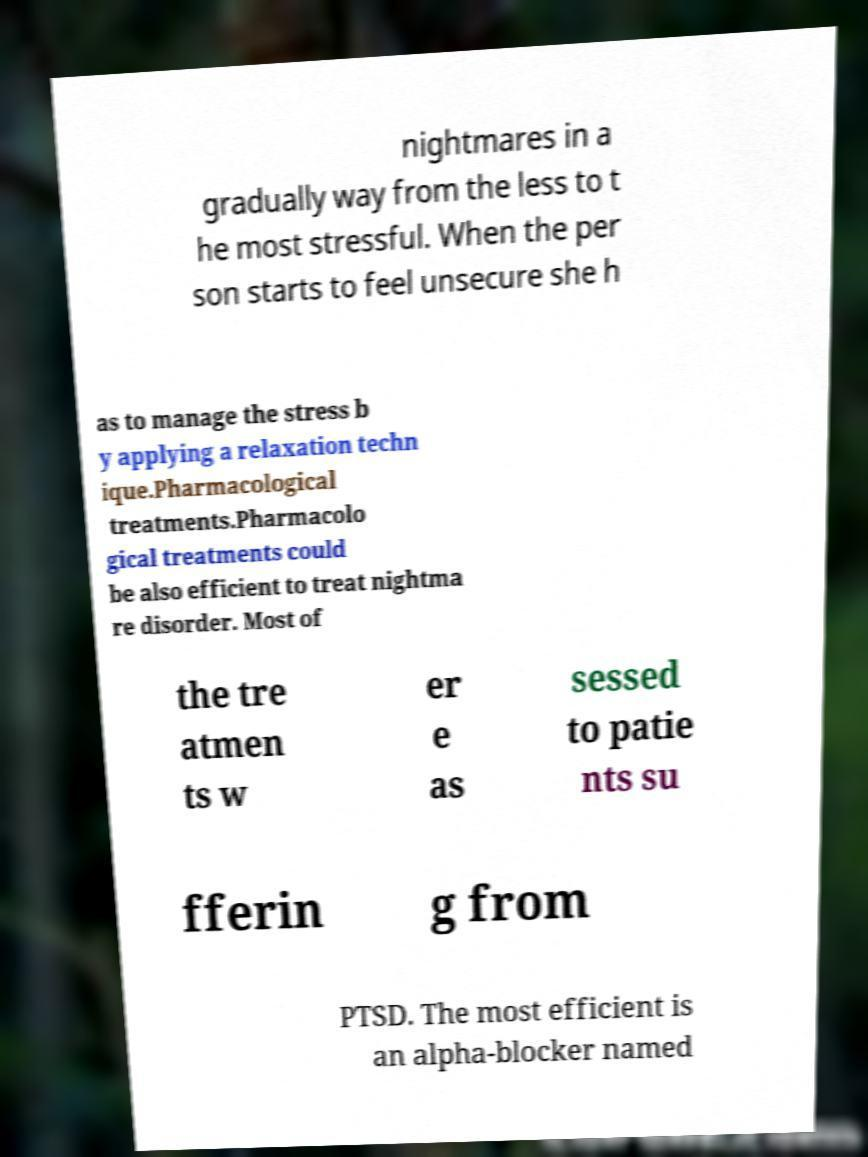Please read and relay the text visible in this image. What does it say? nightmares in a gradually way from the less to t he most stressful. When the per son starts to feel unsecure she h as to manage the stress b y applying a relaxation techn ique.Pharmacological treatments.Pharmacolo gical treatments could be also efficient to treat nightma re disorder. Most of the tre atmen ts w er e as sessed to patie nts su fferin g from PTSD. The most efficient is an alpha-blocker named 